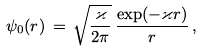Convert formula to latex. <formula><loc_0><loc_0><loc_500><loc_500>\psi _ { 0 } ( r ) \, = \, \sqrt { \frac { \varkappa } { 2 \pi } } \, \frac { \exp ( - \varkappa r ) } { r } \, ,</formula> 